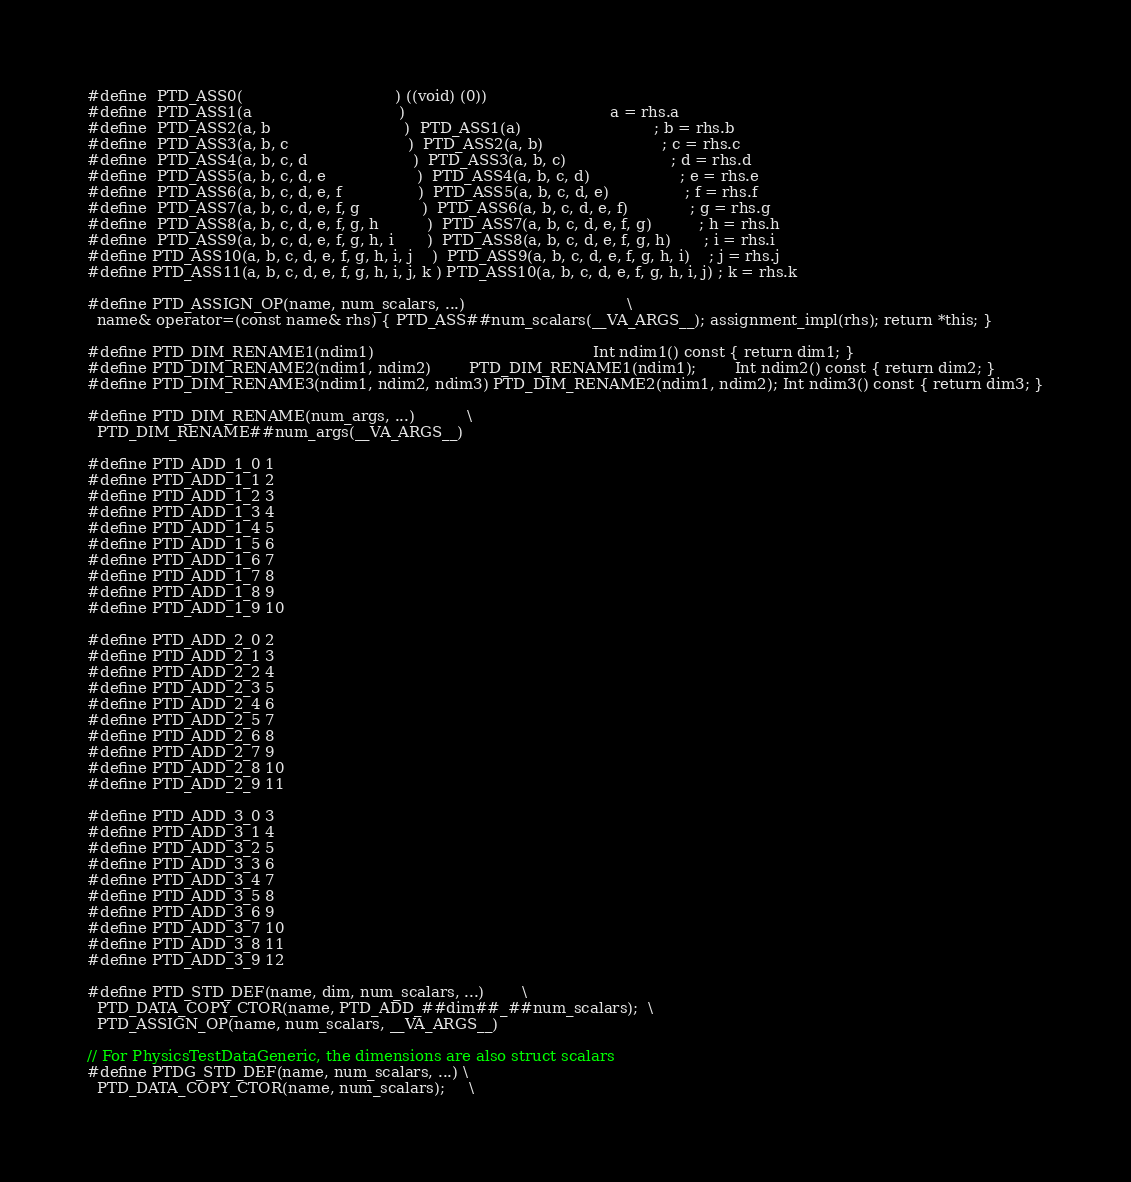<code> <loc_0><loc_0><loc_500><loc_500><_C++_>
#define  PTD_ASS0(                                ) ((void) (0))
#define  PTD_ASS1(a                               )                                           a = rhs.a
#define  PTD_ASS2(a, b                            )  PTD_ASS1(a)                            ; b = rhs.b
#define  PTD_ASS3(a, b, c                         )  PTD_ASS2(a, b)                         ; c = rhs.c
#define  PTD_ASS4(a, b, c, d                      )  PTD_ASS3(a, b, c)                      ; d = rhs.d
#define  PTD_ASS5(a, b, c, d, e                   )  PTD_ASS4(a, b, c, d)                   ; e = rhs.e
#define  PTD_ASS6(a, b, c, d, e, f                )  PTD_ASS5(a, b, c, d, e)                ; f = rhs.f
#define  PTD_ASS7(a, b, c, d, e, f, g             )  PTD_ASS6(a, b, c, d, e, f)             ; g = rhs.g
#define  PTD_ASS8(a, b, c, d, e, f, g, h          )  PTD_ASS7(a, b, c, d, e, f, g)          ; h = rhs.h
#define  PTD_ASS9(a, b, c, d, e, f, g, h, i       )  PTD_ASS8(a, b, c, d, e, f, g, h)       ; i = rhs.i
#define PTD_ASS10(a, b, c, d, e, f, g, h, i, j    )  PTD_ASS9(a, b, c, d, e, f, g, h, i)    ; j = rhs.j
#define PTD_ASS11(a, b, c, d, e, f, g, h, i, j, k ) PTD_ASS10(a, b, c, d, e, f, g, h, i, j) ; k = rhs.k

#define PTD_ASSIGN_OP(name, num_scalars, ...)                                  \
  name& operator=(const name& rhs) { PTD_ASS##num_scalars(__VA_ARGS__); assignment_impl(rhs); return *this; }

#define PTD_DIM_RENAME1(ndim1)                                              Int ndim1() const { return dim1; }
#define PTD_DIM_RENAME2(ndim1, ndim2)        PTD_DIM_RENAME1(ndim1);        Int ndim2() const { return dim2; }
#define PTD_DIM_RENAME3(ndim1, ndim2, ndim3) PTD_DIM_RENAME2(ndim1, ndim2); Int ndim3() const { return dim3; }

#define PTD_DIM_RENAME(num_args, ...)           \
  PTD_DIM_RENAME##num_args(__VA_ARGS__)

#define PTD_ADD_1_0 1
#define PTD_ADD_1_1 2
#define PTD_ADD_1_2 3
#define PTD_ADD_1_3 4
#define PTD_ADD_1_4 5
#define PTD_ADD_1_5 6
#define PTD_ADD_1_6 7
#define PTD_ADD_1_7 8
#define PTD_ADD_1_8 9
#define PTD_ADD_1_9 10

#define PTD_ADD_2_0 2
#define PTD_ADD_2_1 3
#define PTD_ADD_2_2 4
#define PTD_ADD_2_3 5
#define PTD_ADD_2_4 6
#define PTD_ADD_2_5 7
#define PTD_ADD_2_6 8
#define PTD_ADD_2_7 9
#define PTD_ADD_2_8 10
#define PTD_ADD_2_9 11

#define PTD_ADD_3_0 3
#define PTD_ADD_3_1 4
#define PTD_ADD_3_2 5
#define PTD_ADD_3_3 6
#define PTD_ADD_3_4 7
#define PTD_ADD_3_5 8
#define PTD_ADD_3_6 9
#define PTD_ADD_3_7 10
#define PTD_ADD_3_8 11
#define PTD_ADD_3_9 12

#define PTD_STD_DEF(name, dim, num_scalars, ...)        \
  PTD_DATA_COPY_CTOR(name, PTD_ADD_##dim##_##num_scalars);  \
  PTD_ASSIGN_OP(name, num_scalars, __VA_ARGS__)

// For PhysicsTestDataGeneric, the dimensions are also struct scalars
#define PTDG_STD_DEF(name, num_scalars, ...) \
  PTD_DATA_COPY_CTOR(name, num_scalars);     \</code> 